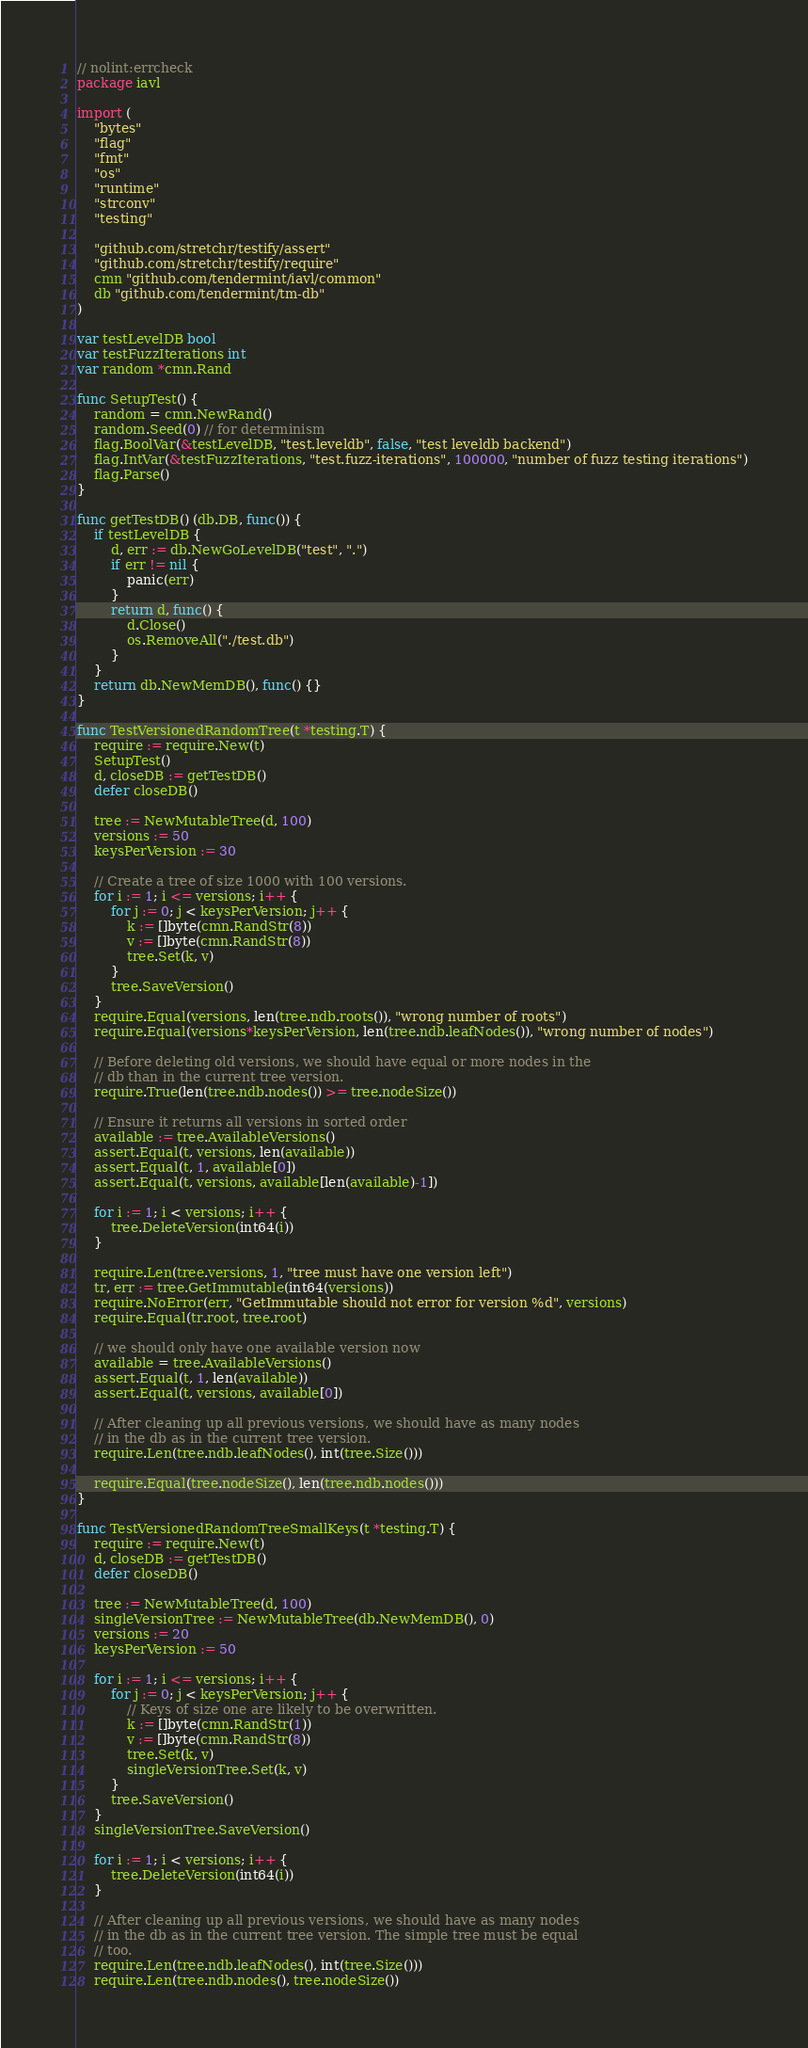Convert code to text. <code><loc_0><loc_0><loc_500><loc_500><_Go_>// nolint:errcheck
package iavl

import (
	"bytes"
	"flag"
	"fmt"
	"os"
	"runtime"
	"strconv"
	"testing"

	"github.com/stretchr/testify/assert"
	"github.com/stretchr/testify/require"
	cmn "github.com/tendermint/iavl/common"
	db "github.com/tendermint/tm-db"
)

var testLevelDB bool
var testFuzzIterations int
var random *cmn.Rand

func SetupTest() {
	random = cmn.NewRand()
	random.Seed(0) // for determinism
	flag.BoolVar(&testLevelDB, "test.leveldb", false, "test leveldb backend")
	flag.IntVar(&testFuzzIterations, "test.fuzz-iterations", 100000, "number of fuzz testing iterations")
	flag.Parse()
}

func getTestDB() (db.DB, func()) {
	if testLevelDB {
		d, err := db.NewGoLevelDB("test", ".")
		if err != nil {
			panic(err)
		}
		return d, func() {
			d.Close()
			os.RemoveAll("./test.db")
		}
	}
	return db.NewMemDB(), func() {}
}

func TestVersionedRandomTree(t *testing.T) {
	require := require.New(t)
	SetupTest()
	d, closeDB := getTestDB()
	defer closeDB()

	tree := NewMutableTree(d, 100)
	versions := 50
	keysPerVersion := 30

	// Create a tree of size 1000 with 100 versions.
	for i := 1; i <= versions; i++ {
		for j := 0; j < keysPerVersion; j++ {
			k := []byte(cmn.RandStr(8))
			v := []byte(cmn.RandStr(8))
			tree.Set(k, v)
		}
		tree.SaveVersion()
	}
	require.Equal(versions, len(tree.ndb.roots()), "wrong number of roots")
	require.Equal(versions*keysPerVersion, len(tree.ndb.leafNodes()), "wrong number of nodes")

	// Before deleting old versions, we should have equal or more nodes in the
	// db than in the current tree version.
	require.True(len(tree.ndb.nodes()) >= tree.nodeSize())

	// Ensure it returns all versions in sorted order
	available := tree.AvailableVersions()
	assert.Equal(t, versions, len(available))
	assert.Equal(t, 1, available[0])
	assert.Equal(t, versions, available[len(available)-1])

	for i := 1; i < versions; i++ {
		tree.DeleteVersion(int64(i))
	}

	require.Len(tree.versions, 1, "tree must have one version left")
	tr, err := tree.GetImmutable(int64(versions))
	require.NoError(err, "GetImmutable should not error for version %d", versions)
	require.Equal(tr.root, tree.root)

	// we should only have one available version now
	available = tree.AvailableVersions()
	assert.Equal(t, 1, len(available))
	assert.Equal(t, versions, available[0])

	// After cleaning up all previous versions, we should have as many nodes
	// in the db as in the current tree version.
	require.Len(tree.ndb.leafNodes(), int(tree.Size()))

	require.Equal(tree.nodeSize(), len(tree.ndb.nodes()))
}

func TestVersionedRandomTreeSmallKeys(t *testing.T) {
	require := require.New(t)
	d, closeDB := getTestDB()
	defer closeDB()

	tree := NewMutableTree(d, 100)
	singleVersionTree := NewMutableTree(db.NewMemDB(), 0)
	versions := 20
	keysPerVersion := 50

	for i := 1; i <= versions; i++ {
		for j := 0; j < keysPerVersion; j++ {
			// Keys of size one are likely to be overwritten.
			k := []byte(cmn.RandStr(1))
			v := []byte(cmn.RandStr(8))
			tree.Set(k, v)
			singleVersionTree.Set(k, v)
		}
		tree.SaveVersion()
	}
	singleVersionTree.SaveVersion()

	for i := 1; i < versions; i++ {
		tree.DeleteVersion(int64(i))
	}

	// After cleaning up all previous versions, we should have as many nodes
	// in the db as in the current tree version. The simple tree must be equal
	// too.
	require.Len(tree.ndb.leafNodes(), int(tree.Size()))
	require.Len(tree.ndb.nodes(), tree.nodeSize())</code> 